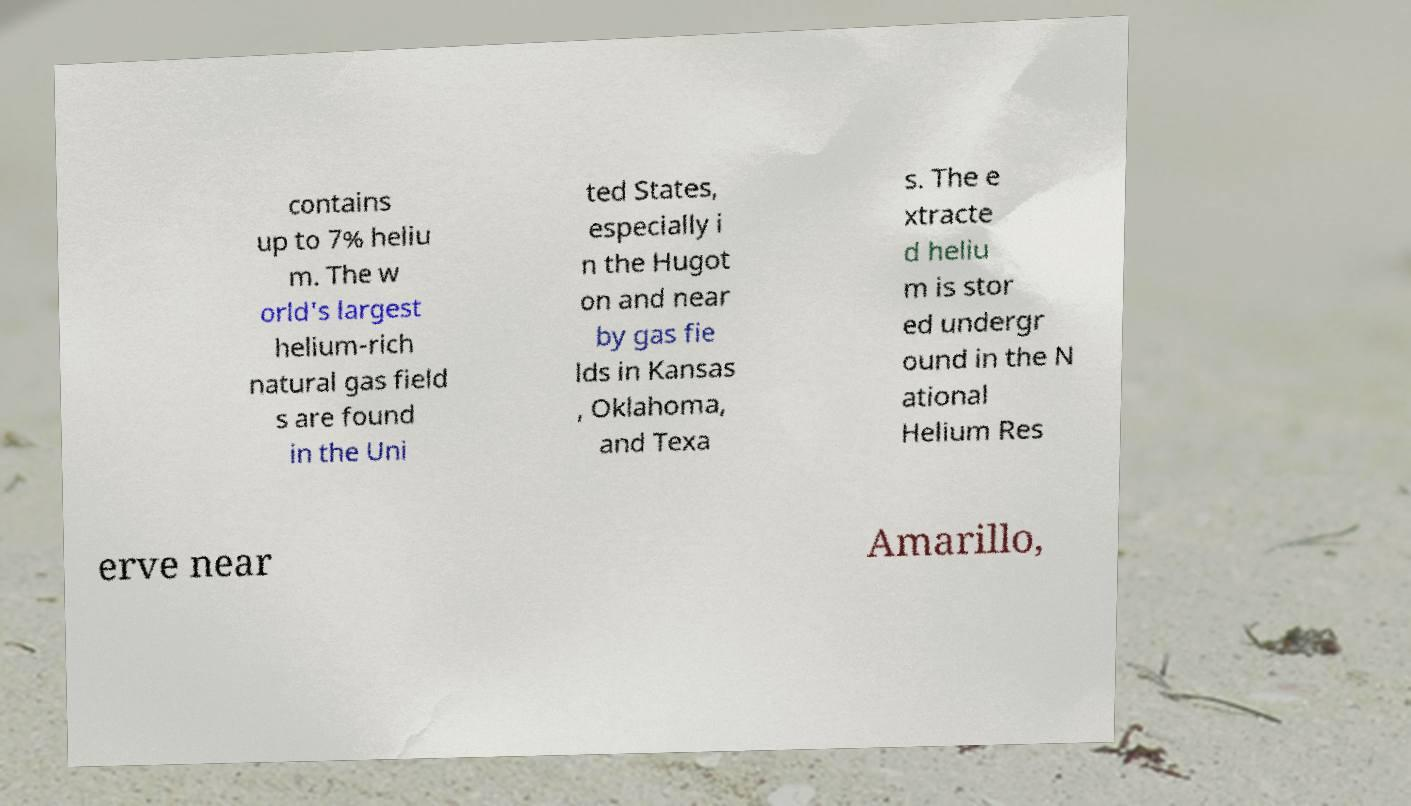Can you accurately transcribe the text from the provided image for me? contains up to 7% heliu m. The w orld's largest helium-rich natural gas field s are found in the Uni ted States, especially i n the Hugot on and near by gas fie lds in Kansas , Oklahoma, and Texa s. The e xtracte d heliu m is stor ed undergr ound in the N ational Helium Res erve near Amarillo, 